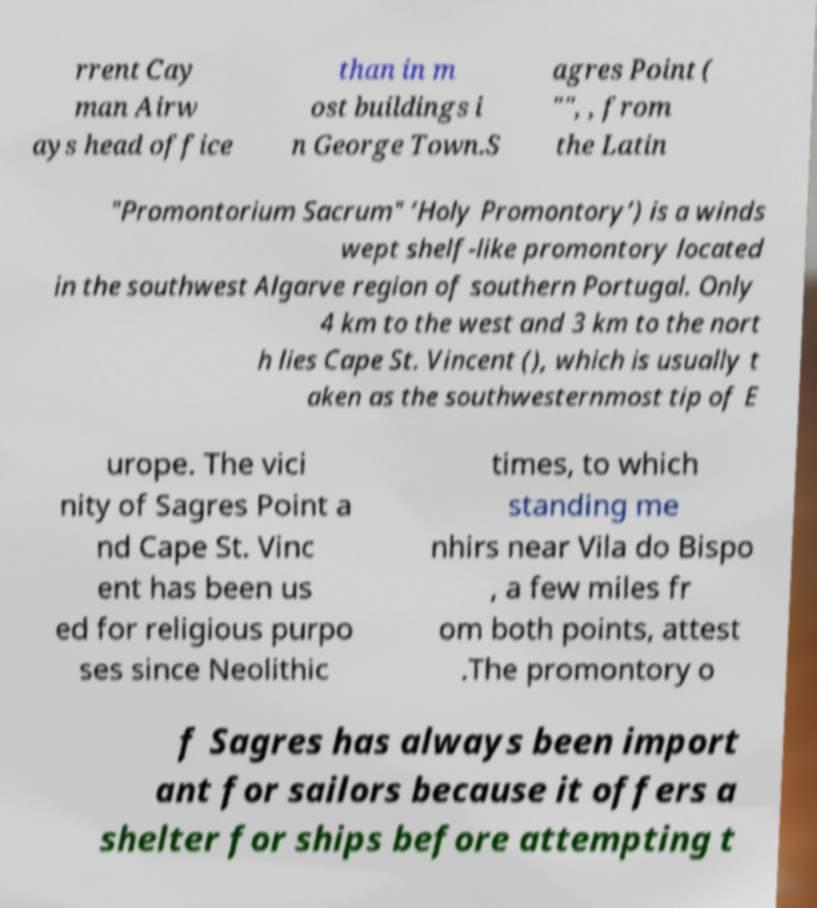Can you read and provide the text displayed in the image?This photo seems to have some interesting text. Can you extract and type it out for me? rrent Cay man Airw ays head office than in m ost buildings i n George Town.S agres Point ( "", , from the Latin "Promontorium Sacrum" ‘Holy Promontory’) is a winds wept shelf-like promontory located in the southwest Algarve region of southern Portugal. Only 4 km to the west and 3 km to the nort h lies Cape St. Vincent (), which is usually t aken as the southwesternmost tip of E urope. The vici nity of Sagres Point a nd Cape St. Vinc ent has been us ed for religious purpo ses since Neolithic times, to which standing me nhirs near Vila do Bispo , a few miles fr om both points, attest .The promontory o f Sagres has always been import ant for sailors because it offers a shelter for ships before attempting t 